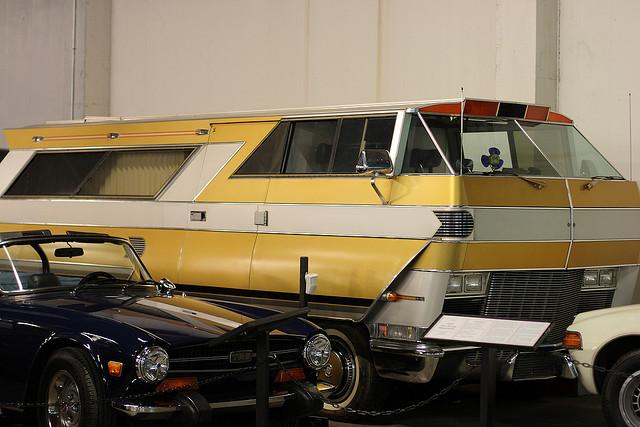Is this a new bus?
Be succinct. No. Do these vehicles have drivers?
Concise answer only. No. Is this in a museum?
Short answer required. Yes. 